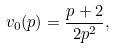Convert formula to latex. <formula><loc_0><loc_0><loc_500><loc_500>v _ { 0 } ( p ) = \frac { p + 2 } { 2 p ^ { 2 } } ,</formula> 